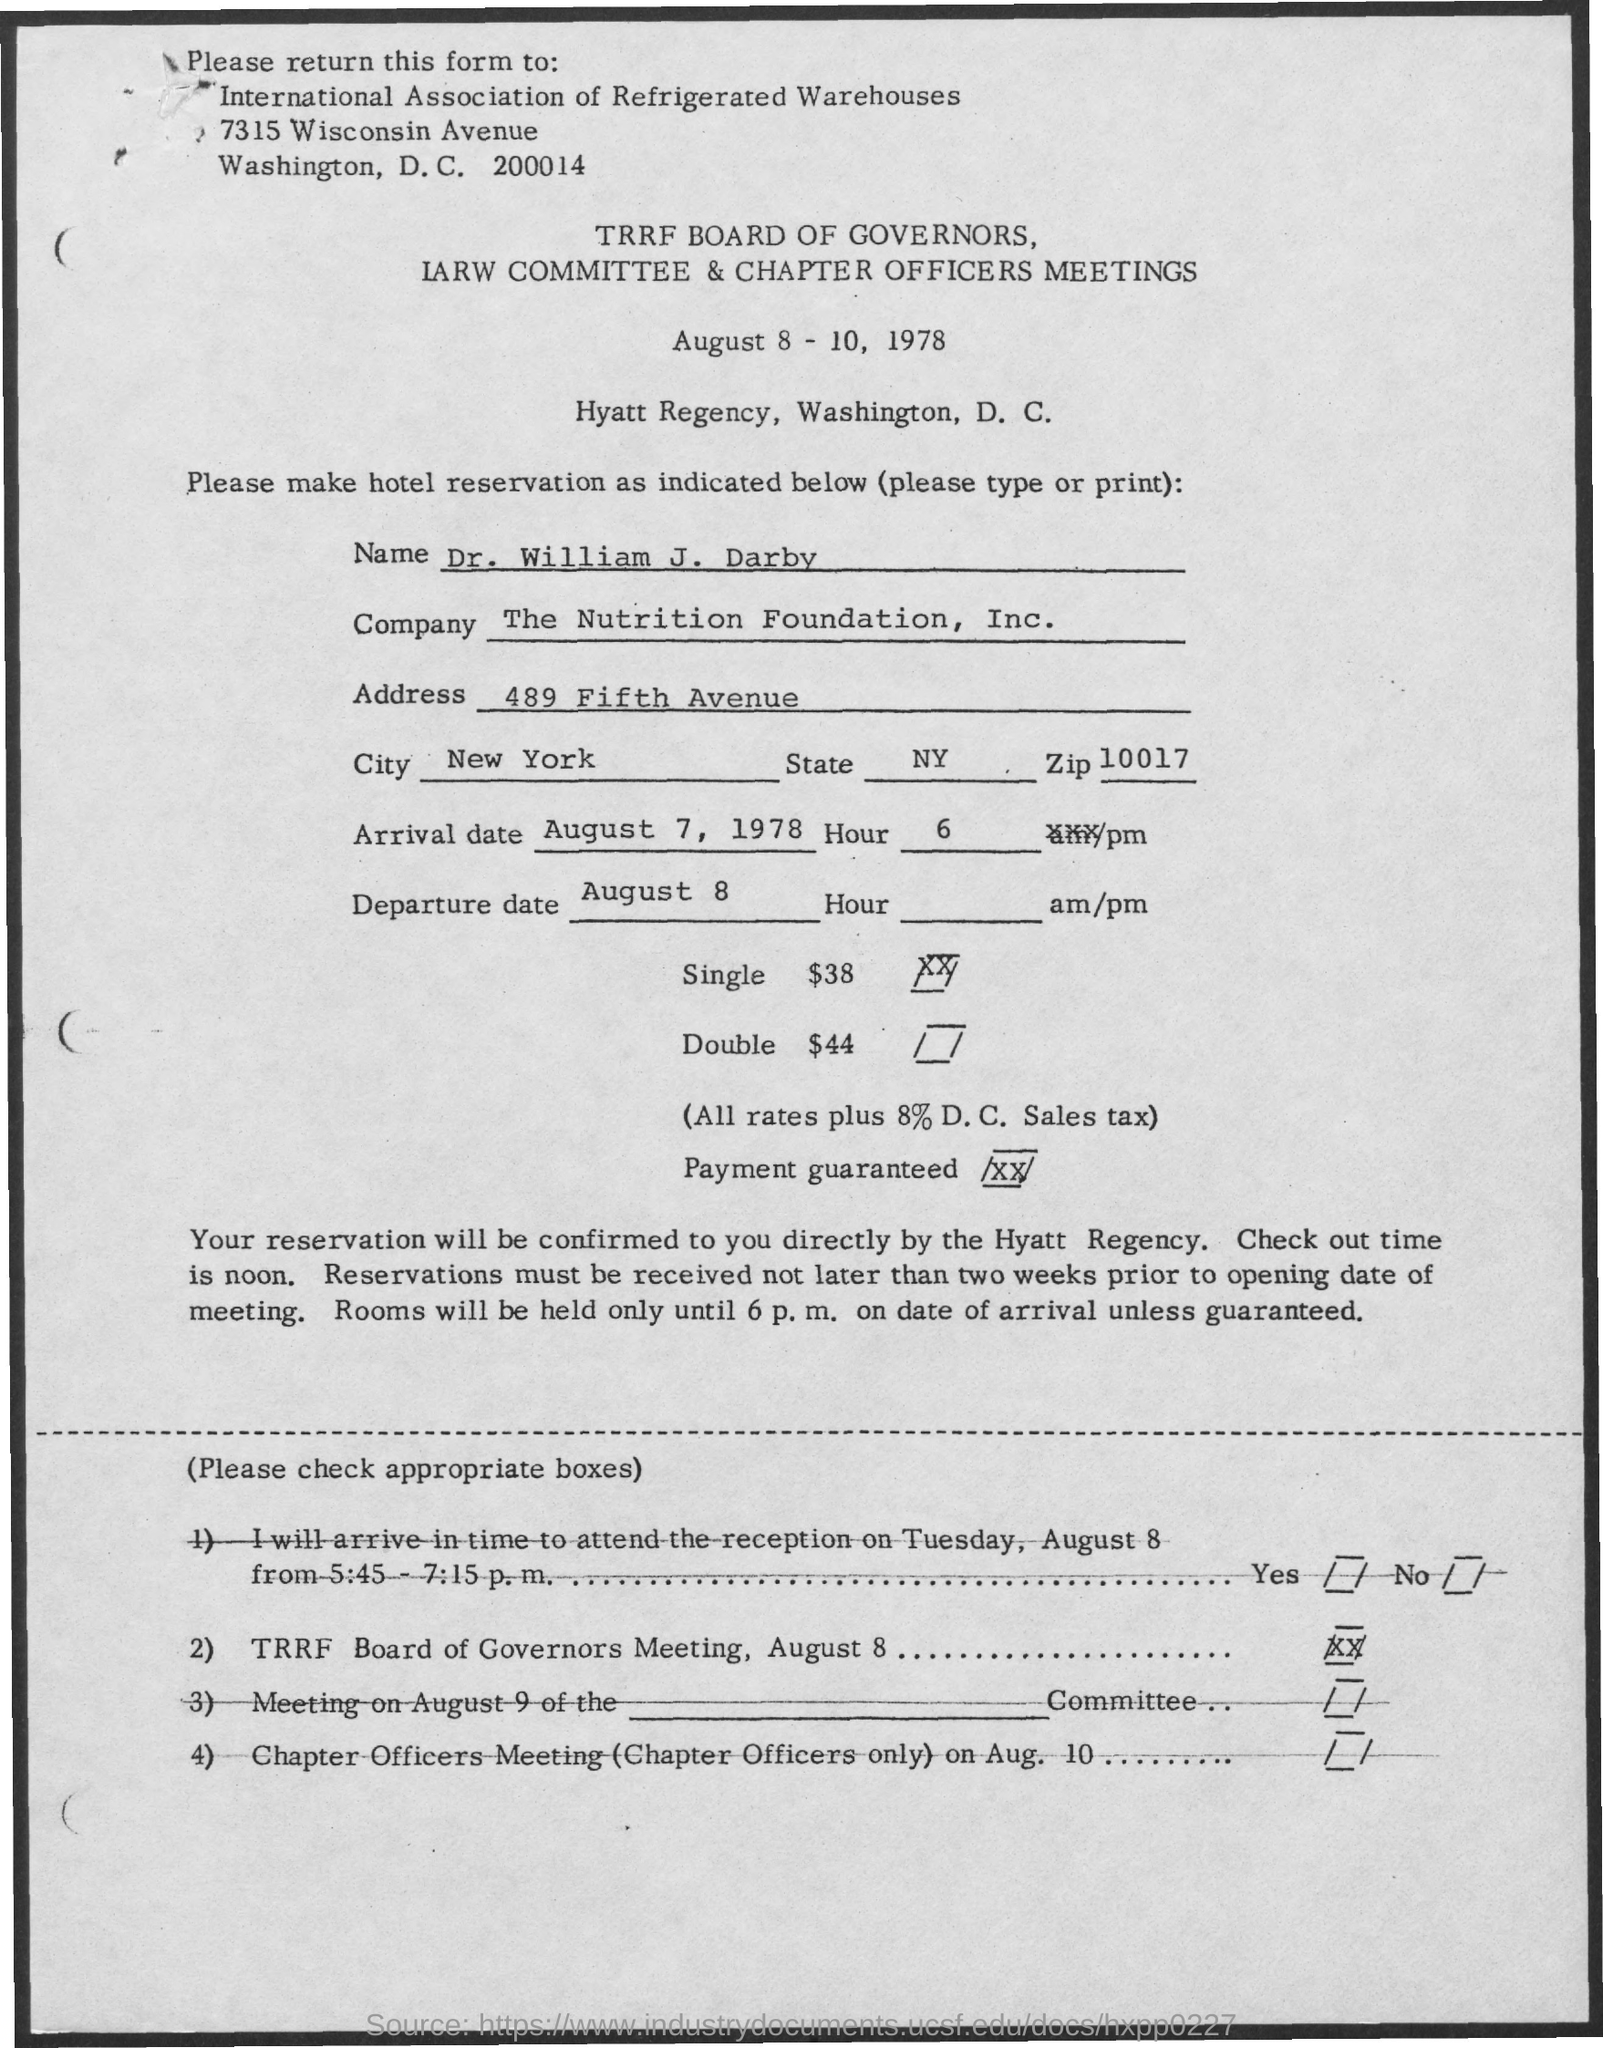When is the meeting?
Offer a terse response. August 8 - 10, 1978. Where is the meeting?
Your answer should be very brief. Hyatt Regency, Washington, D. C. What is the Name?
Offer a terse response. Dr. William J. Darby. What is the Company?
Ensure brevity in your answer.  The Nutrition Foundation, Inc. What is the Address?
Make the answer very short. 489 Fifth Avenue. What is the City?
Your response must be concise. New York. What is the State?
Make the answer very short. NY. What is the Zip?
Your answer should be compact. 10017. What is the Arrival Date?
Offer a very short reply. August 7, 1978. What is the departure Date?
Provide a short and direct response. August 8. 